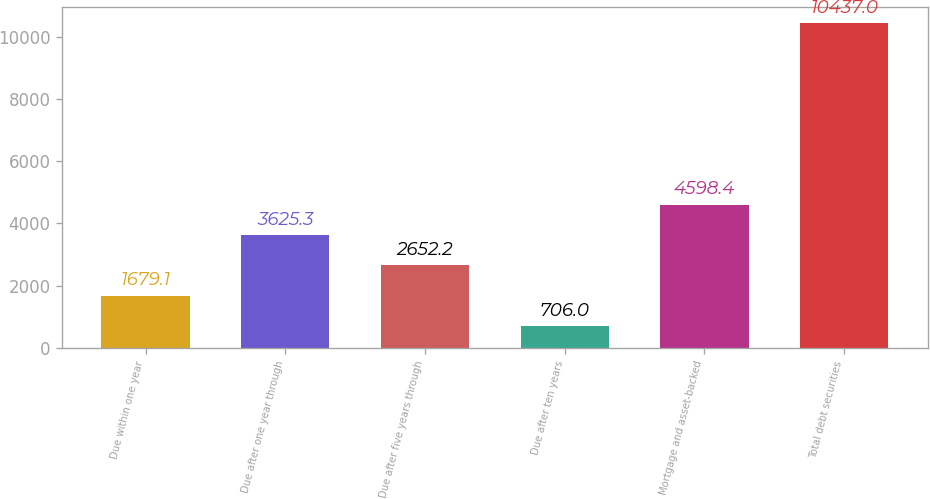Convert chart. <chart><loc_0><loc_0><loc_500><loc_500><bar_chart><fcel>Due within one year<fcel>Due after one year through<fcel>Due after five years through<fcel>Due after ten years<fcel>Mortgage and asset-backed<fcel>Total debt securities<nl><fcel>1679.1<fcel>3625.3<fcel>2652.2<fcel>706<fcel>4598.4<fcel>10437<nl></chart> 